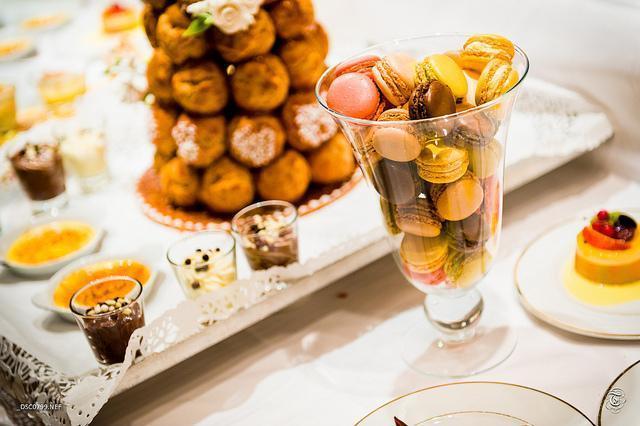How many donuts are there?
Give a very brief answer. 7. How many cups are visible?
Give a very brief answer. 6. How many bowls can be seen?
Give a very brief answer. 2. 